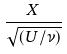<formula> <loc_0><loc_0><loc_500><loc_500>\frac { X } { \sqrt { ( U / \nu ) } }</formula> 